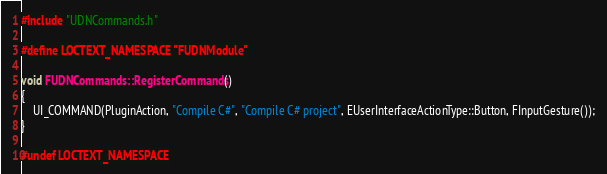Convert code to text. <code><loc_0><loc_0><loc_500><loc_500><_C++_>#include "UDNCommands.h"

#define LOCTEXT_NAMESPACE "FUDNModule"

void FUDNCommands::RegisterCommands()
{
	UI_COMMAND(PluginAction, "Compile C#", "Compile C# project", EUserInterfaceActionType::Button, FInputGesture());
}

#undef LOCTEXT_NAMESPACE
</code> 